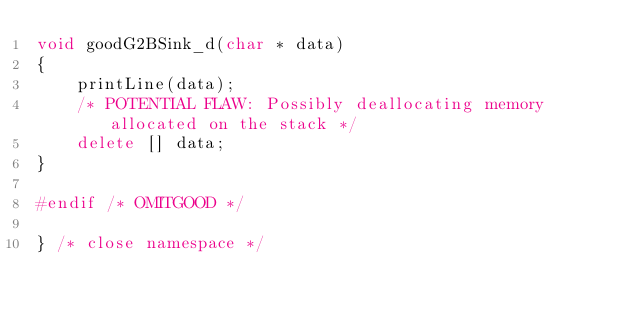Convert code to text. <code><loc_0><loc_0><loc_500><loc_500><_C++_>void goodG2BSink_d(char * data)
{
    printLine(data);
    /* POTENTIAL FLAW: Possibly deallocating memory allocated on the stack */
    delete [] data;
}

#endif /* OMITGOOD */

} /* close namespace */
</code> 